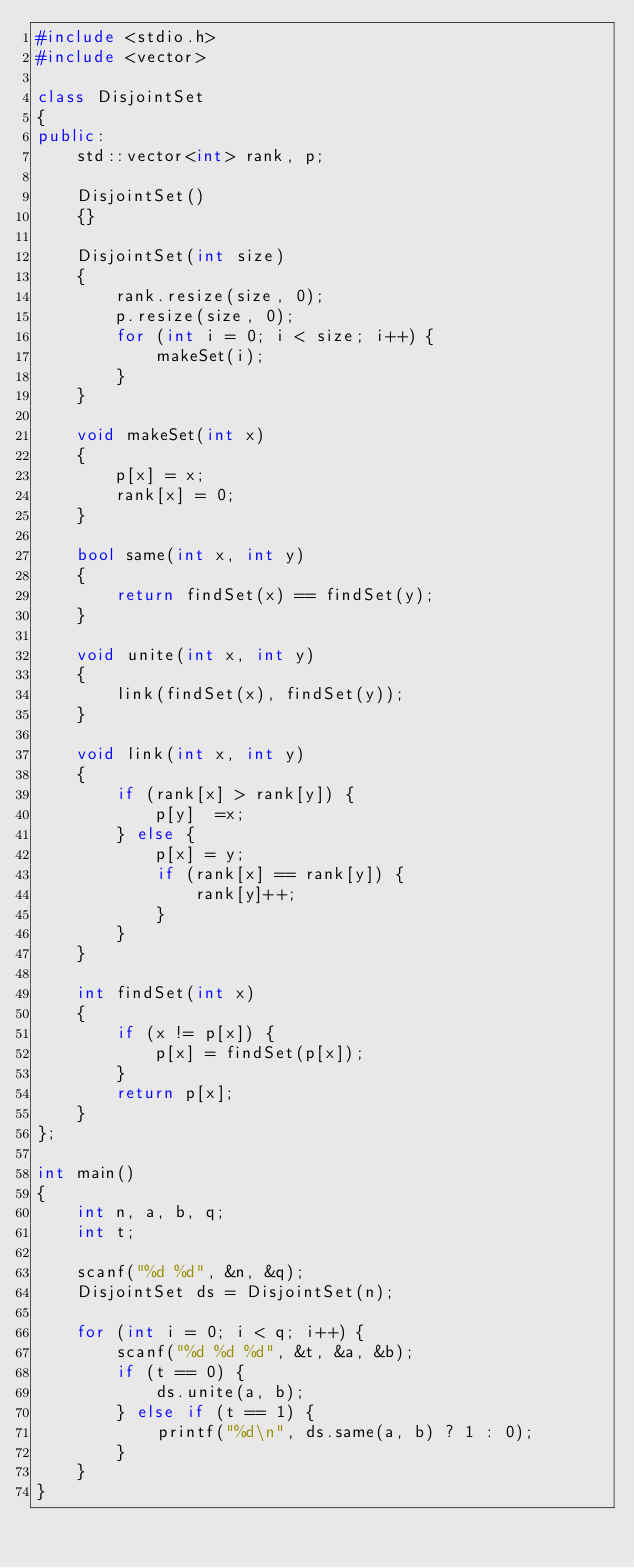<code> <loc_0><loc_0><loc_500><loc_500><_C++_>#include <stdio.h>
#include <vector>

class DisjointSet
{
public:
    std::vector<int> rank, p;

    DisjointSet()
    {}

    DisjointSet(int size)
    {
        rank.resize(size, 0);
        p.resize(size, 0);
        for (int i = 0; i < size; i++) {
            makeSet(i);
        }
    }

    void makeSet(int x)
    {
        p[x] = x;
        rank[x] = 0;
    }

    bool same(int x, int y)
    {
        return findSet(x) == findSet(y);
    }

    void unite(int x, int y)
    {
        link(findSet(x), findSet(y));
    }

    void link(int x, int y)
    {
        if (rank[x] > rank[y]) {
            p[y]  =x;
        } else {
            p[x] = y;
            if (rank[x] == rank[y]) {
                rank[y]++;
            }
        }
    }

    int findSet(int x)
    {
        if (x != p[x]) {
            p[x] = findSet(p[x]);
        }
        return p[x];
    }
};

int main()
{
    int n, a, b, q;
    int t;

    scanf("%d %d", &n, &q);
    DisjointSet ds = DisjointSet(n);

    for (int i = 0; i < q; i++) {
        scanf("%d %d %d", &t, &a, &b);
        if (t == 0) {
            ds.unite(a, b);
        } else if (t == 1) {
            printf("%d\n", ds.same(a, b) ? 1 : 0);
        }
    }
}
</code> 